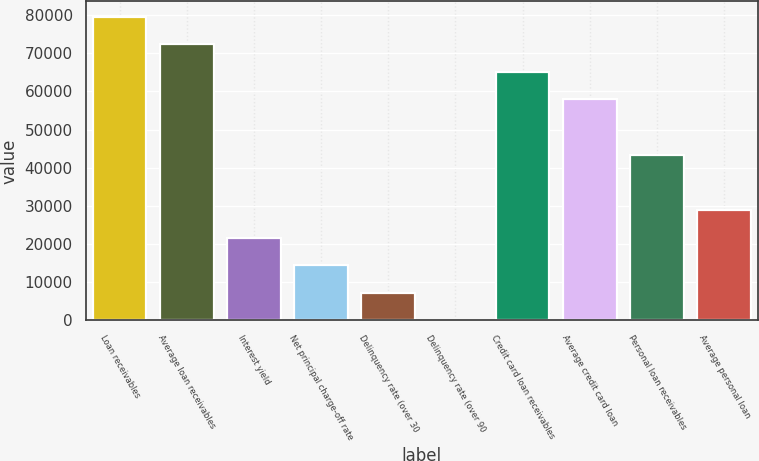Convert chart to OTSL. <chart><loc_0><loc_0><loc_500><loc_500><bar_chart><fcel>Loan receivables<fcel>Average loan receivables<fcel>Interest yield<fcel>Net principal charge-off rate<fcel>Delinquency rate (over 30<fcel>Delinquency rate (over 90<fcel>Credit card loan receivables<fcel>Average credit card loan<fcel>Personal loan receivables<fcel>Average personal loan<nl><fcel>79623.4<fcel>72385<fcel>21716<fcel>14477.6<fcel>7239.18<fcel>0.76<fcel>65146.5<fcel>57908.1<fcel>43431.3<fcel>28954.4<nl></chart> 